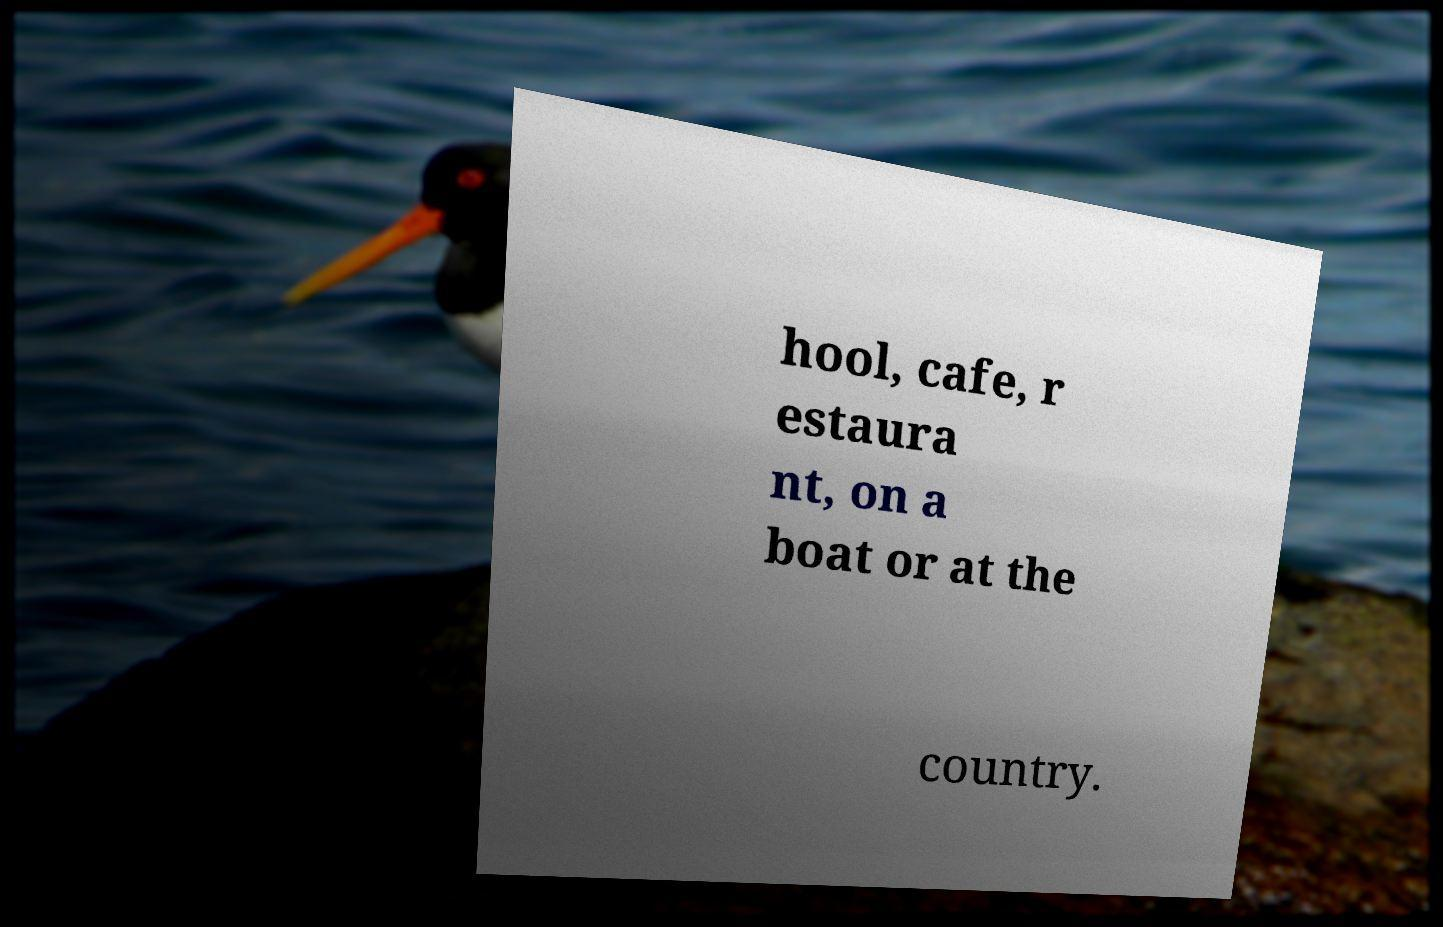Could you assist in decoding the text presented in this image and type it out clearly? hool, cafe, r estaura nt, on a boat or at the country. 